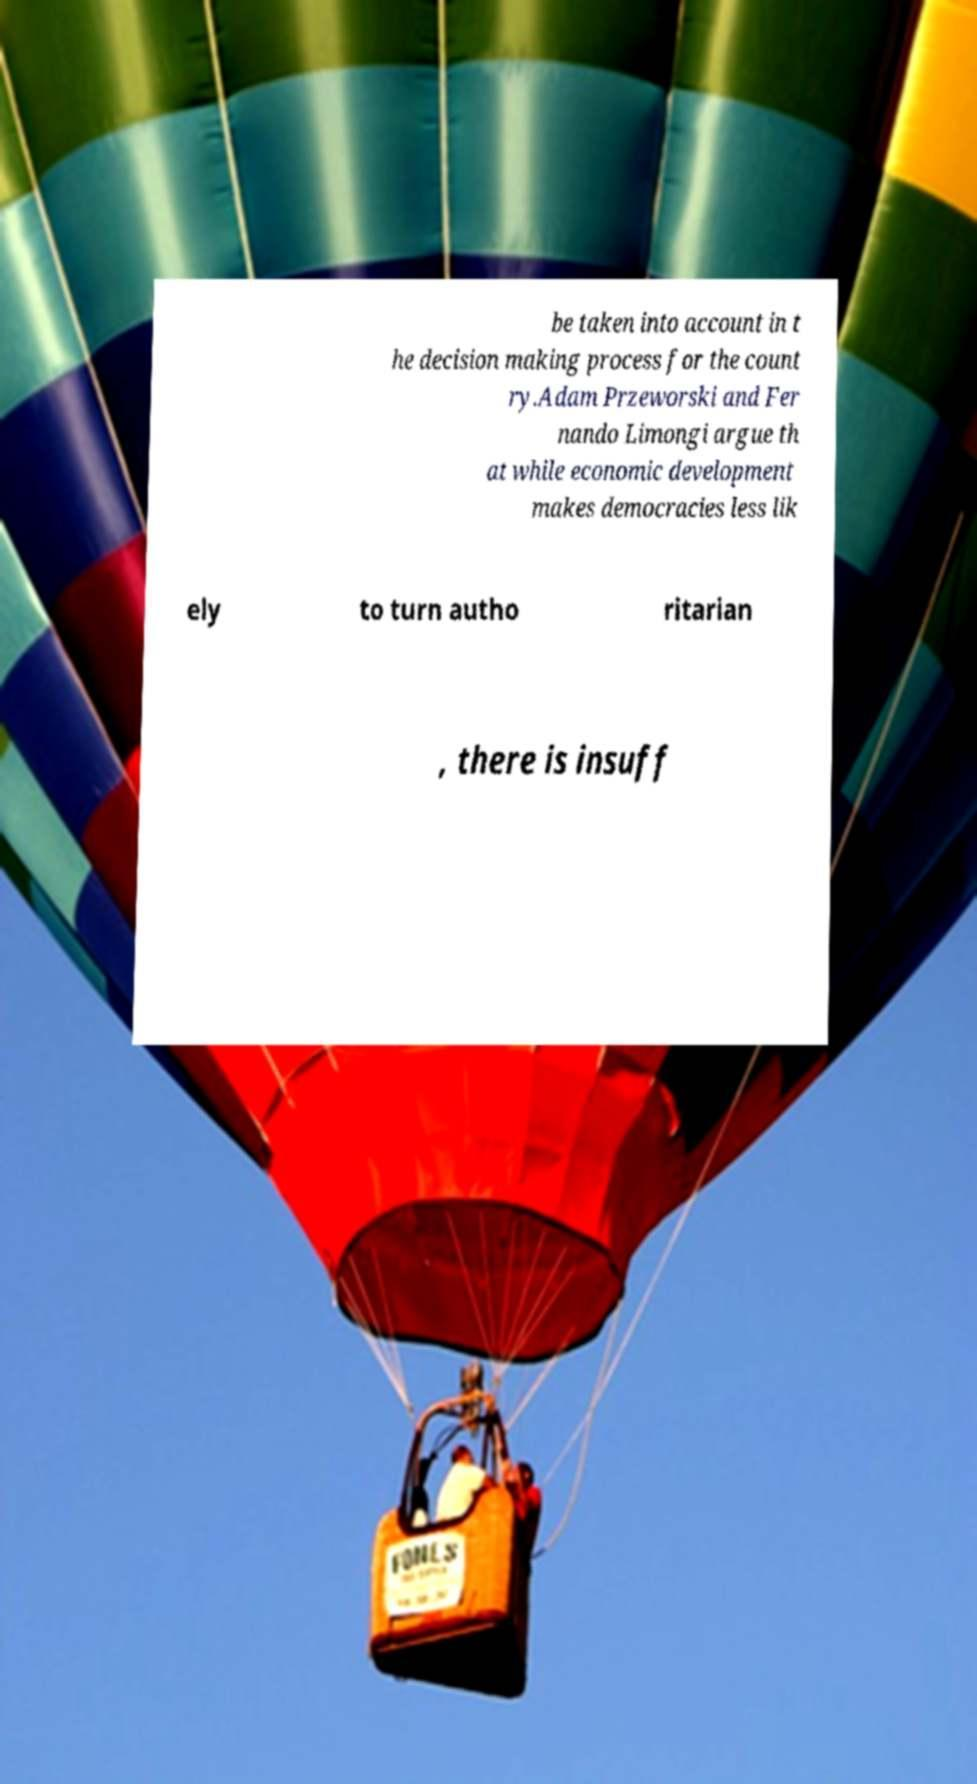Please read and relay the text visible in this image. What does it say? be taken into account in t he decision making process for the count ry.Adam Przeworski and Fer nando Limongi argue th at while economic development makes democracies less lik ely to turn autho ritarian , there is insuff 